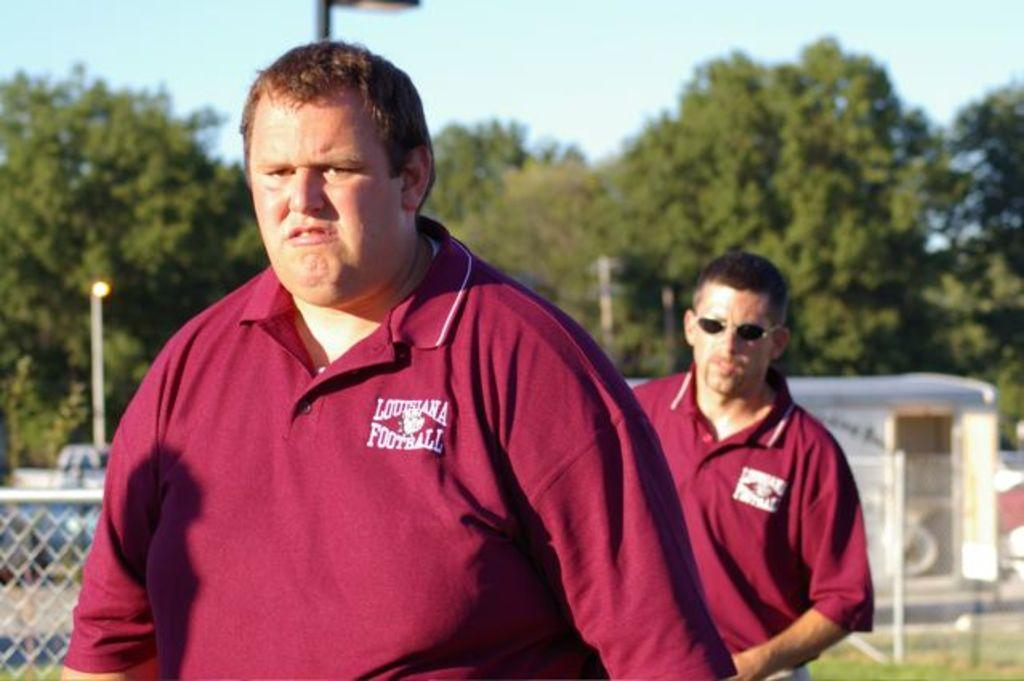Provide a one-sentence caption for the provided image. Two men are standing outside with Louisiana Football shirts on. 